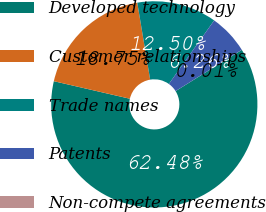Convert chart. <chart><loc_0><loc_0><loc_500><loc_500><pie_chart><fcel>Developed technology<fcel>Customer relationships<fcel>Trade names<fcel>Patents<fcel>Non-compete agreements<nl><fcel>62.48%<fcel>18.75%<fcel>12.5%<fcel>6.26%<fcel>0.01%<nl></chart> 